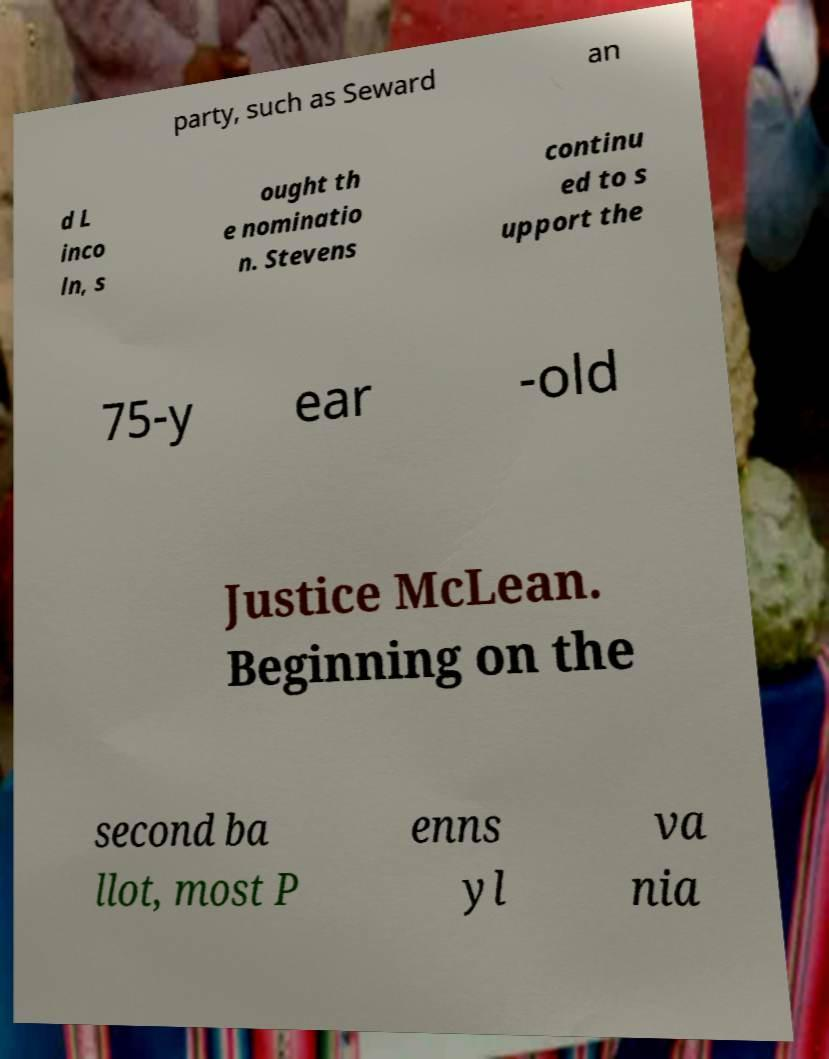Please identify and transcribe the text found in this image. party, such as Seward an d L inco ln, s ought th e nominatio n. Stevens continu ed to s upport the 75-y ear -old Justice McLean. Beginning on the second ba llot, most P enns yl va nia 